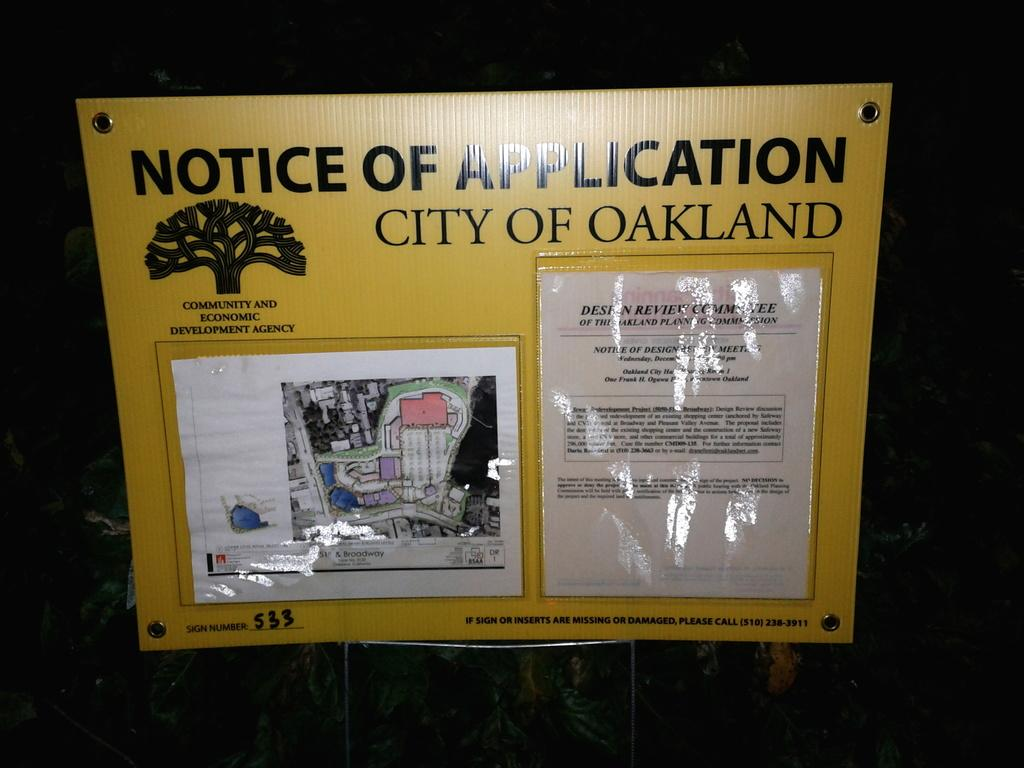<image>
Write a terse but informative summary of the picture. A Notice of Application sign for the City of Oakland 